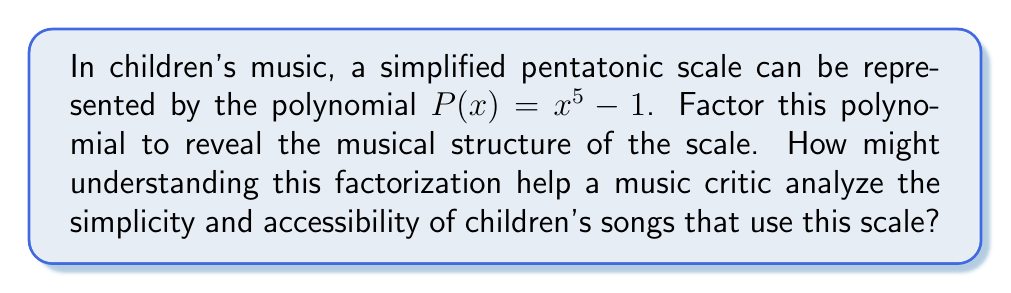Show me your answer to this math problem. Let's approach this step-by-step:

1) The polynomial $P(x) = x^5 - 1$ is in the form of a difference of powers: $a^n - b^n$.

2) For odd $n$, $a^n - b^n$ can be factored as $(a-b)(a^{n-1} + a^{n-2}b + ... + ab^{n-2} + b^{n-1})$.

3) In our case, $n = 5$, $a = x$, and $b = 1$. So we have:

   $x^5 - 1 = (x-1)(x^4 + x^3 + x^2 + x + 1)$

4) The factor $(x-1)$ represents the root note of the scale.

5) The factor $(x^4 + x^3 + x^2 + x + 1)$ represents the other four notes of the pentatonic scale.

6) This factorization reveals that the pentatonic scale is built on a simple relationship between the root note and the other four notes.

7) For a music critic, understanding this structure helps to analyze why children's songs using this scale are often simple and accessible:
   - The root note (represented by $(x-1)$) provides a strong tonal center.
   - The other four notes (represented by $(x^4 + x^3 + x^2 + x + 1)$) create a harmonious relationship with the root.
   - The absence of semitones (half steps) in this scale makes it easier for children to sing and remember melodies.

8) This mathematical representation allows the critic to draw connections between the scale's structure and its frequent use in children's music, highlighting how its simplicity contributes to the genre's characteristics.
Answer: $(x-1)(x^4 + x^3 + x^2 + x + 1)$ 